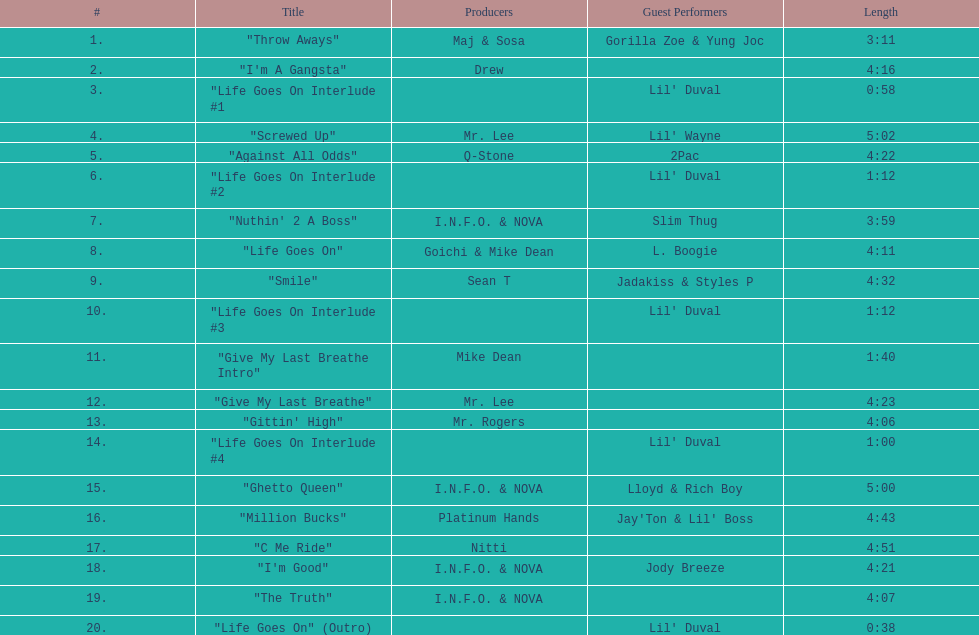What is the longest track on the album? "Screwed Up". Could you parse the entire table as a dict? {'header': ['#', 'Title', 'Producers', 'Guest Performers', 'Length'], 'rows': [['1.', '"Throw Aways"', 'Maj & Sosa', 'Gorilla Zoe & Yung Joc', '3:11'], ['2.', '"I\'m A Gangsta"', 'Drew', '', '4:16'], ['3.', '"Life Goes On Interlude #1', '', "Lil' Duval", '0:58'], ['4.', '"Screwed Up"', 'Mr. Lee', "Lil' Wayne", '5:02'], ['5.', '"Against All Odds"', 'Q-Stone', '2Pac', '4:22'], ['6.', '"Life Goes On Interlude #2', '', "Lil' Duval", '1:12'], ['7.', '"Nuthin\' 2 A Boss"', 'I.N.F.O. & NOVA', 'Slim Thug', '3:59'], ['8.', '"Life Goes On"', 'Goichi & Mike Dean', 'L. Boogie', '4:11'], ['9.', '"Smile"', 'Sean T', 'Jadakiss & Styles P', '4:32'], ['10.', '"Life Goes On Interlude #3', '', "Lil' Duval", '1:12'], ['11.', '"Give My Last Breathe Intro"', 'Mike Dean', '', '1:40'], ['12.', '"Give My Last Breathe"', 'Mr. Lee', '', '4:23'], ['13.', '"Gittin\' High"', 'Mr. Rogers', '', '4:06'], ['14.', '"Life Goes On Interlude #4', '', "Lil' Duval", '1:00'], ['15.', '"Ghetto Queen"', 'I.N.F.O. & NOVA', 'Lloyd & Rich Boy', '5:00'], ['16.', '"Million Bucks"', 'Platinum Hands', "Jay'Ton & Lil' Boss", '4:43'], ['17.', '"C Me Ride"', 'Nitti', '', '4:51'], ['18.', '"I\'m Good"', 'I.N.F.O. & NOVA', 'Jody Breeze', '4:21'], ['19.', '"The Truth"', 'I.N.F.O. & NOVA', '', '4:07'], ['20.', '"Life Goes On" (Outro)', '', "Lil' Duval", '0:38']]} 